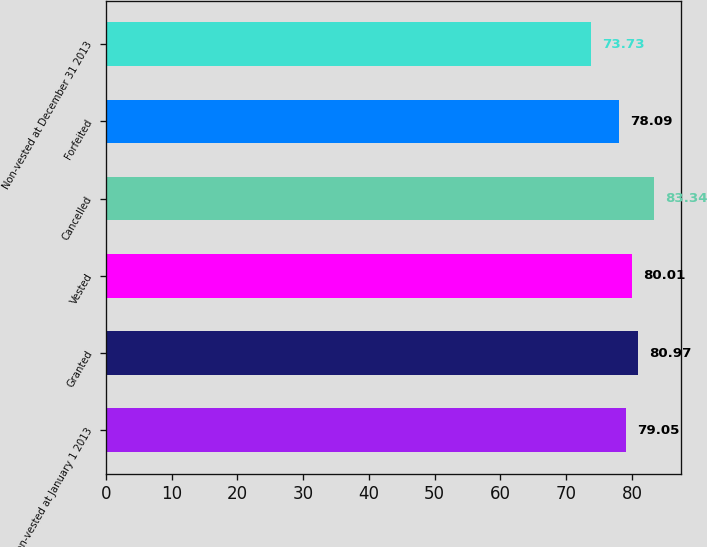<chart> <loc_0><loc_0><loc_500><loc_500><bar_chart><fcel>Non-vested at January 1 2013<fcel>Granted<fcel>Vested<fcel>Cancelled<fcel>Forfeited<fcel>Non-vested at December 31 2013<nl><fcel>79.05<fcel>80.97<fcel>80.01<fcel>83.34<fcel>78.09<fcel>73.73<nl></chart> 